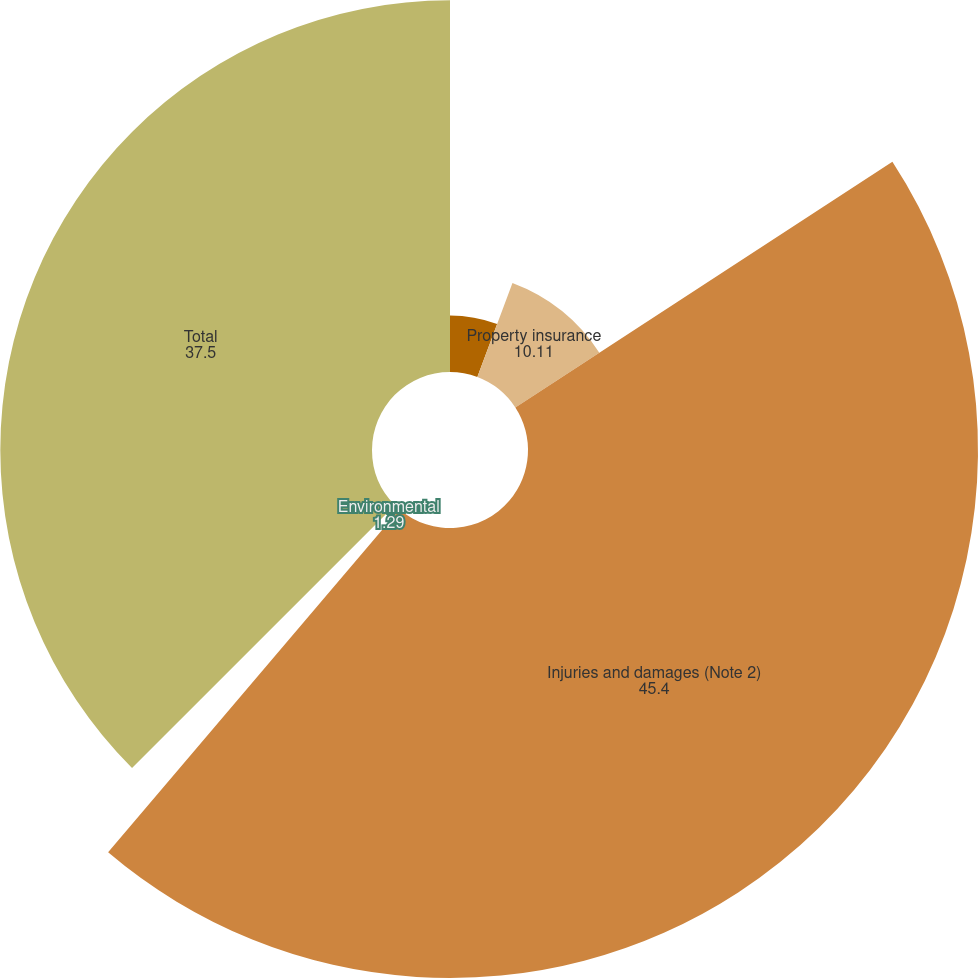<chart> <loc_0><loc_0><loc_500><loc_500><pie_chart><fcel>Doubtful Accounts<fcel>Property insurance<fcel>Injuries and damages (Note 2)<fcel>Environmental<fcel>Total<nl><fcel>5.7%<fcel>10.11%<fcel>45.4%<fcel>1.29%<fcel>37.5%<nl></chart> 